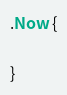<code> <loc_0><loc_0><loc_500><loc_500><_CSS_>.Now {

}</code> 